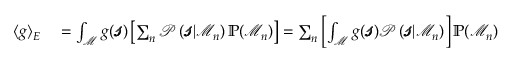<formula> <loc_0><loc_0><loc_500><loc_500>\begin{array} { r l } { \langle g \rangle _ { E } } & = \int _ { \mathcal { M } } g ( \pm b { \ m a t h s c r { s } } ) \left [ \sum _ { n } \mathcal { P } \left ( \pm b { \ m a t h s c r { s } } | \mathcal { M } _ { n } \right ) \mathbb { P } ( \mathcal { M } _ { n } ) \right ] = \sum _ { n } \left [ \int _ { \mathcal { M } } g ( \pm b { \ m a t h s c r { s } } ) \mathcal { P } \left ( \pm b { \ m a t h s c r { s } } | \mathcal { M } _ { n } \right ) \right ] \mathbb { P } ( \mathcal { M } _ { n } ) } \end{array}</formula> 